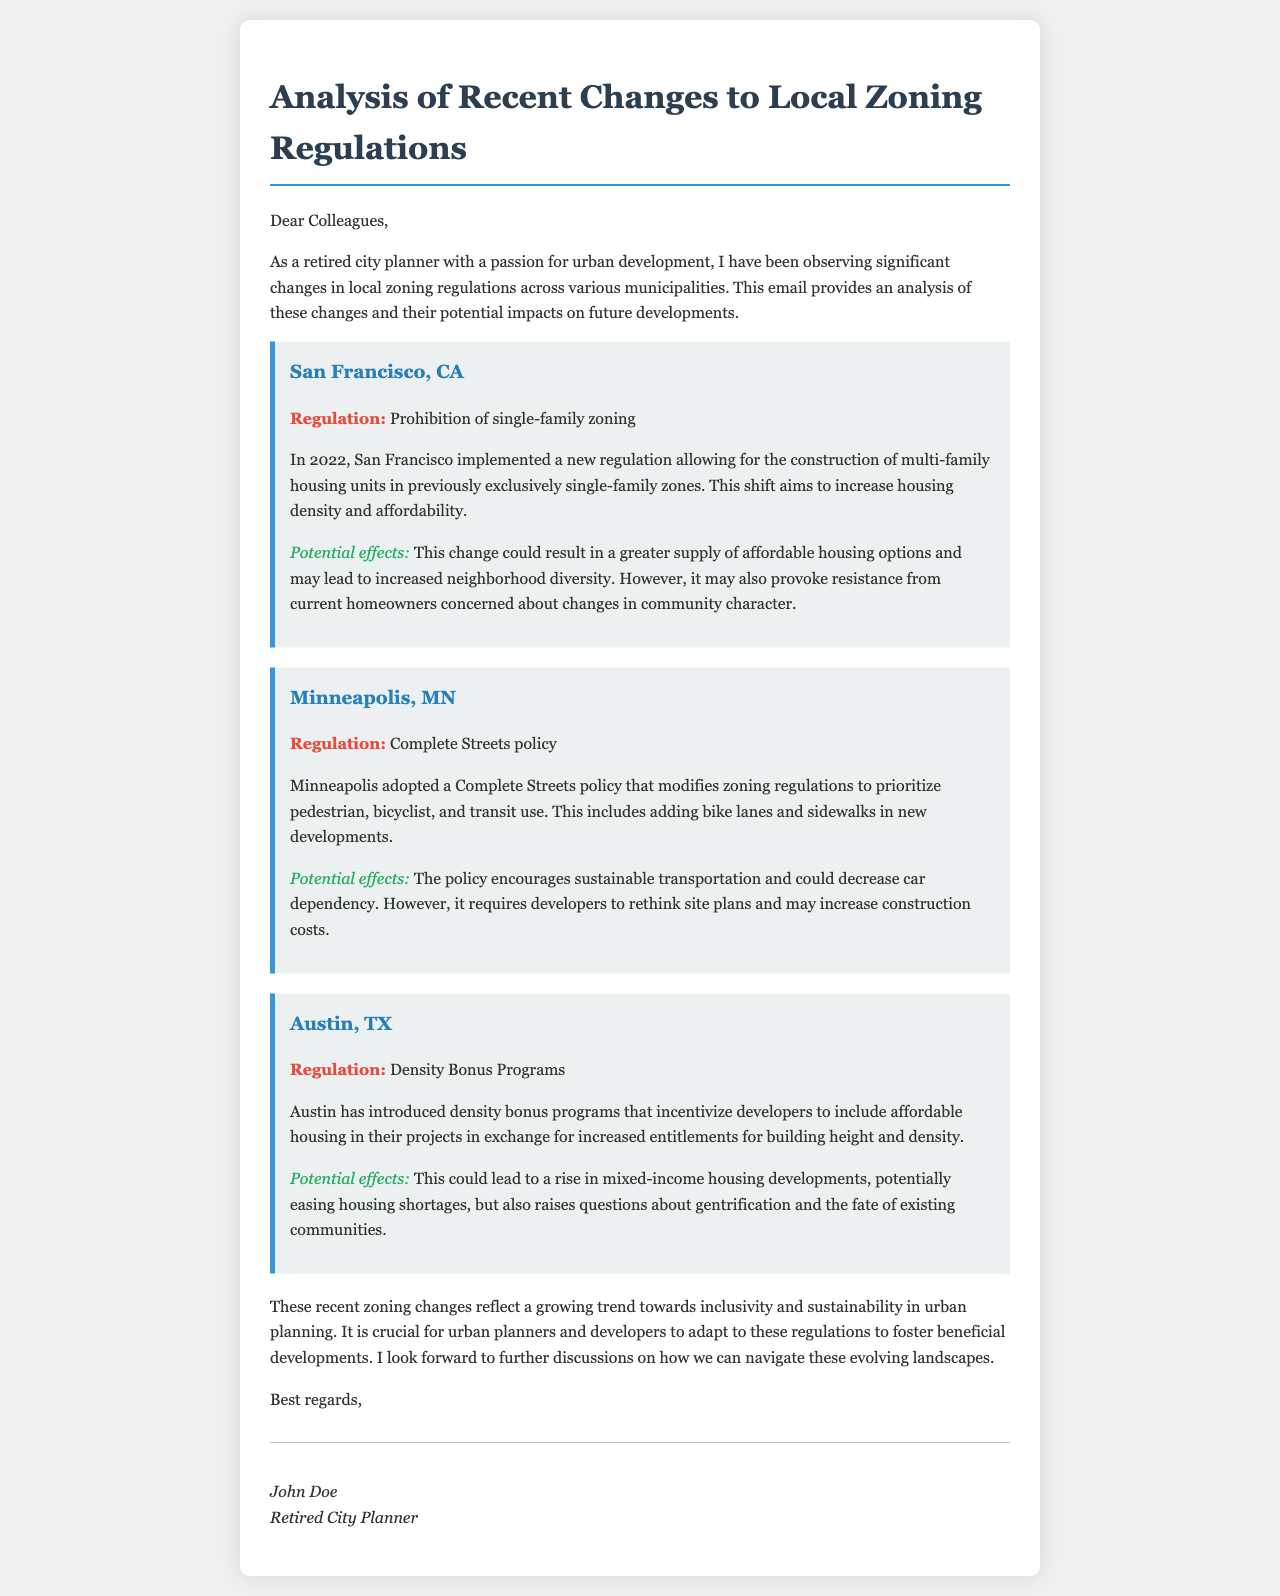What is the regulation implemented in San Francisco? The regulation noted in San Francisco is the prohibition of single-family zoning, allowing for multi-family housing in those areas.
Answer: Prohibition of single-family zoning What year did San Francisco implement the new zoning regulation? The document states that San Francisco implemented the new regulation in 2022.
Answer: 2022 What is the main focus of Minneapolis's Complete Streets policy? The Complete Streets policy focuses on prioritizing pedestrian, bicyclist, and transit use in urban planning.
Answer: Pedestrian, bicyclist, and transit use What incentives does Austin's density bonus program provide to developers? The density bonus program incentivizes developers to include affordable housing in exchange for increased height and density entitlements.
Answer: Increased height and density What potential issue may arise in Austin due to the density bonus programs? The document mentions that gentrification and the fate of existing communities may raise questions due to the density bonus programs.
Answer: Gentrification What is the overall trend reflected in the recent zoning changes mentioned? The document indicates that the overall trend is toward inclusivity and sustainability in urban planning.
Answer: Inclusivity and sustainability Who is the author of the document? The author, as stated at the end of the document, is John Doe.
Answer: John Doe Which city adopted a Complete Streets policy? The city that adopted a Complete Streets policy is Minneapolis, MN.
Answer: Minneapolis, MN 